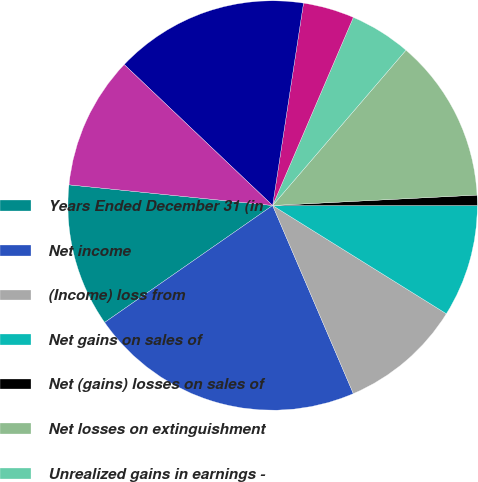Convert chart to OTSL. <chart><loc_0><loc_0><loc_500><loc_500><pie_chart><fcel>Years Ended December 31 (in<fcel>Net income<fcel>(Income) loss from<fcel>Net gains on sales of<fcel>Net (gains) losses on sales of<fcel>Net losses on extinguishment<fcel>Unrealized gains in earnings -<fcel>Equity in income from equity<fcel>Depreciation and other<fcel>Impairments of assets<nl><fcel>11.29%<fcel>21.77%<fcel>9.68%<fcel>8.87%<fcel>0.81%<fcel>12.9%<fcel>4.84%<fcel>4.04%<fcel>15.32%<fcel>10.48%<nl></chart> 